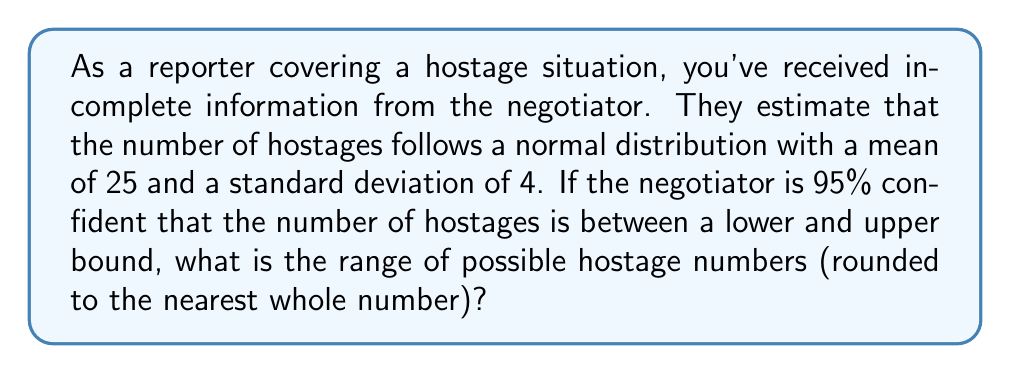Help me with this question. Let's approach this step-by-step:

1) We know that the number of hostages follows a normal distribution with:
   $\mu = 25$ (mean)
   $\sigma = 4$ (standard deviation)

2) For a 95% confidence interval in a normal distribution, we use a z-score of 1.96 (rounded to two decimal places).

3) The formula for a confidence interval is:
   $CI = \mu \pm (z \cdot \frac{\sigma}{\sqrt{n}})$

   However, since we're dealing with a population parameter rather than a sample, we can simplify this to:
   $CI = \mu \pm (z \cdot \sigma)$

4) Plugging in our values:
   $CI = 25 \pm (1.96 \cdot 4)$

5) Simplifying:
   $CI = 25 \pm 7.84$

6) This gives us:
   Lower bound: $25 - 7.84 = 17.16$
   Upper bound: $25 + 7.84 = 32.84$

7) Rounding to the nearest whole number (as hostages must be whole people):
   Lower bound: 17
   Upper bound: 33

Therefore, the negotiator is 95% confident that the number of hostages is between 17 and 33.
Answer: 17 to 33 hostages 